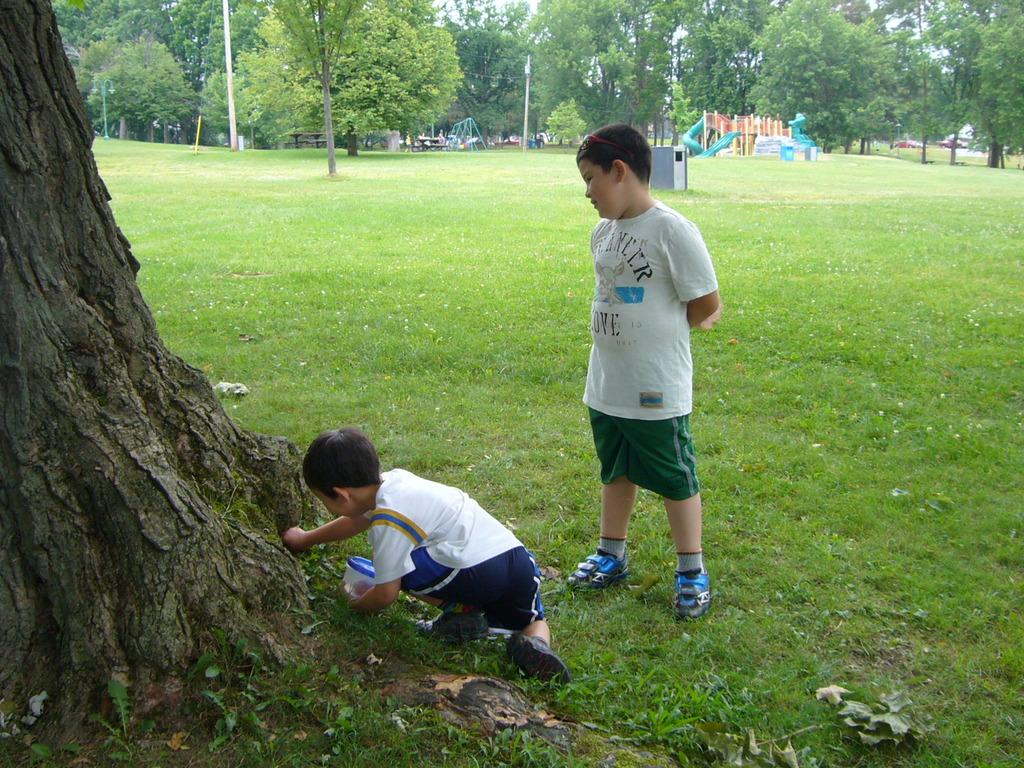How many kids are in the image? There are 2 kids in the image. What are the kids doing in the image? The kids are playing near a tree. What type of surface are the kids playing on? The kids are on green grass. What can be seen in the background of the image? The area around the kids is surrounded by trees. What other structures are present in the image? There are poles visible in the image, and swings are present. What type of location is depicted in the image? There is a playground in the image. What type of key is used to unlock the swings in the image? There is no key present in the image, and the swings do not require a key to operate. 